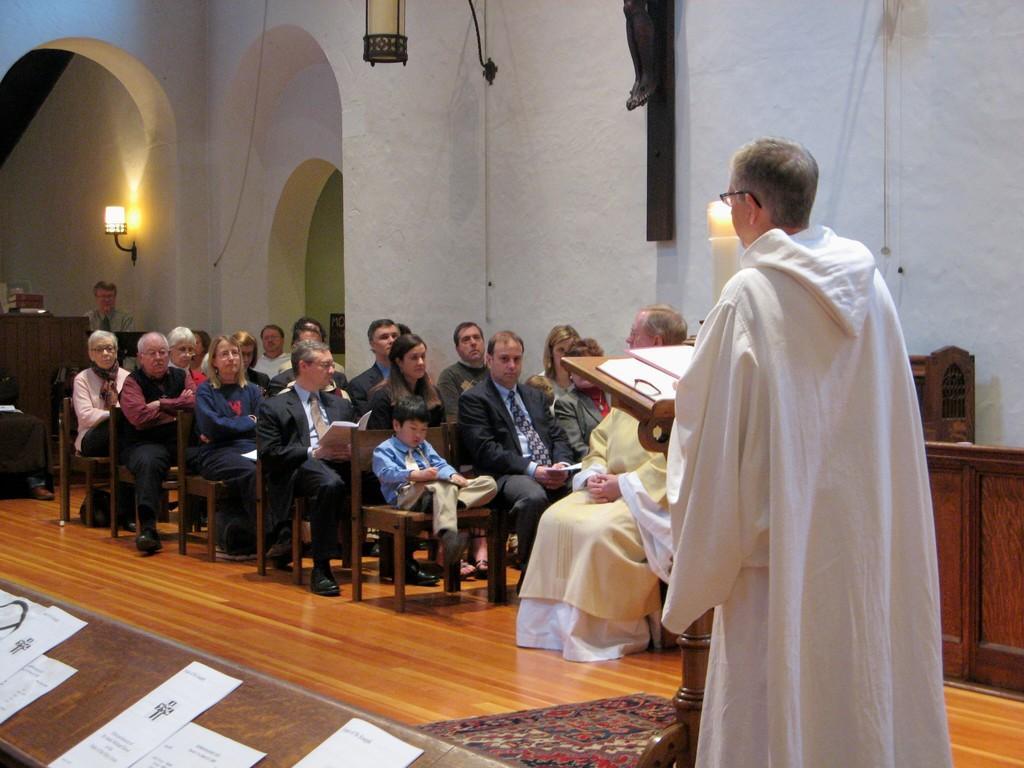Could you give a brief overview of what you see in this image? In the bottom left corner of the image there is a table with papers. And there is a man standing and in front of him there is a podium with papers. And on the floor there is a floor mat. There are few people sitting on the benches. And on the right side of the image there is a cupboard. And in the background there is a wall with black pole, arches and lamps. And also there is a table. Behind the table there is a man.  